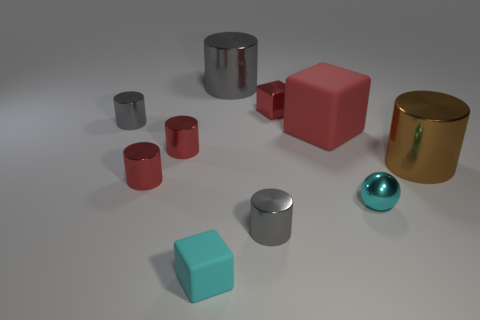Subtract all yellow cylinders. How many red blocks are left? 2 Subtract all red rubber cubes. How many cubes are left? 2 Subtract all gray cylinders. How many cylinders are left? 3 Subtract all spheres. How many objects are left? 9 Subtract 1 cubes. How many cubes are left? 2 Subtract 0 cyan cylinders. How many objects are left? 10 Subtract all brown cylinders. Subtract all brown blocks. How many cylinders are left? 5 Subtract all large red matte things. Subtract all brown metallic things. How many objects are left? 8 Add 5 brown cylinders. How many brown cylinders are left? 6 Add 4 small cyan metal objects. How many small cyan metal objects exist? 5 